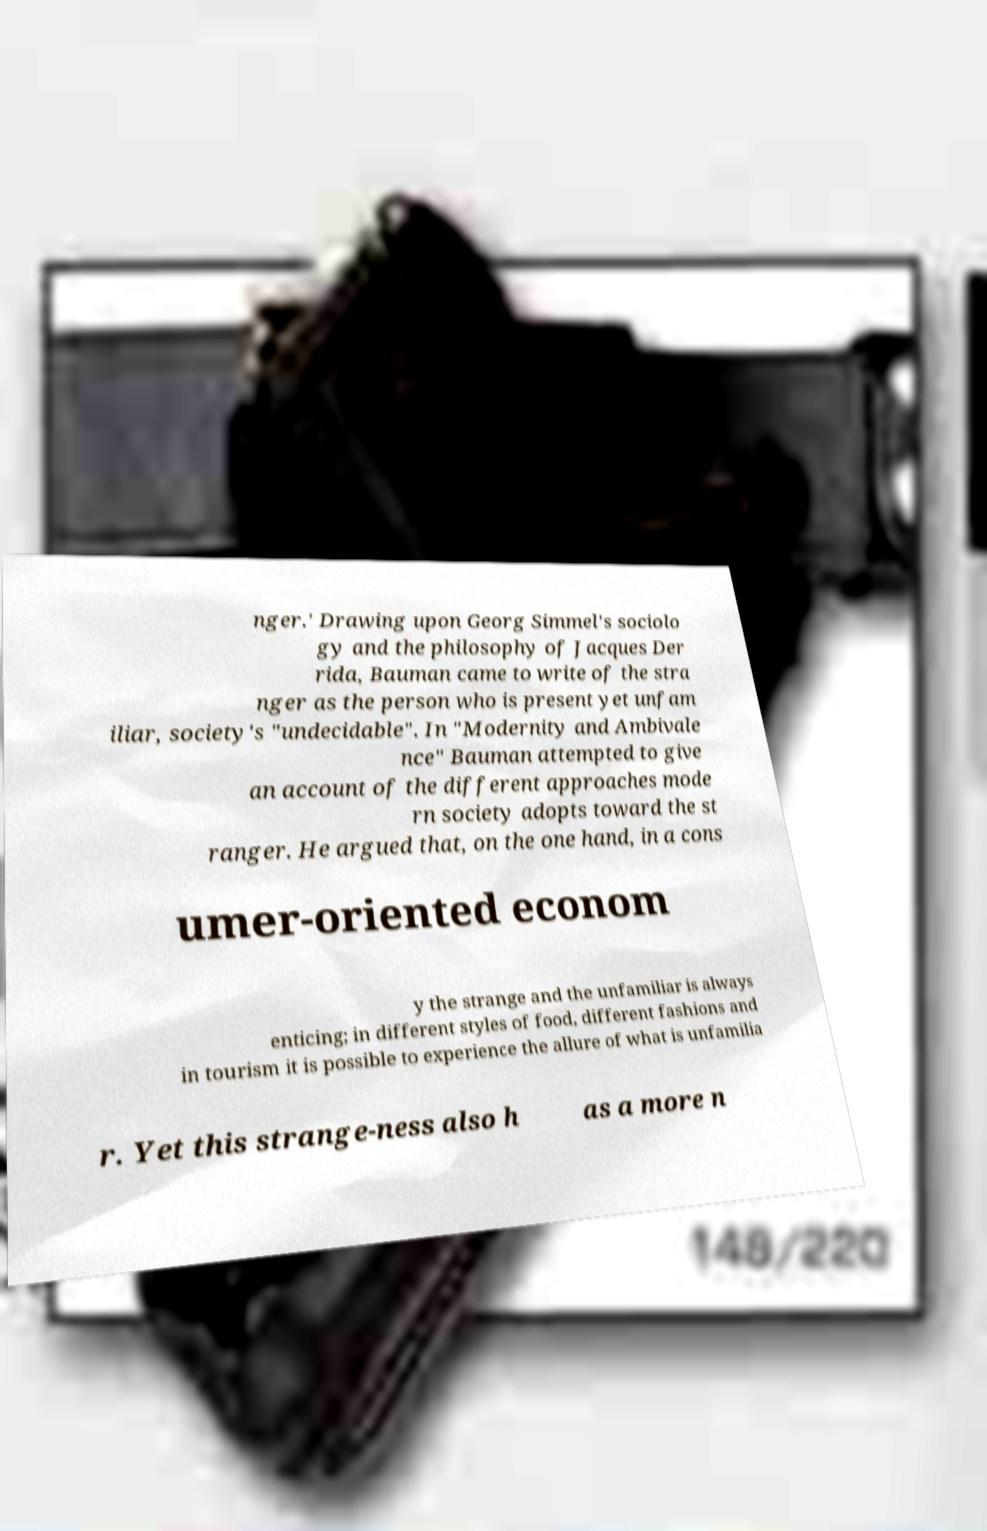Please identify and transcribe the text found in this image. nger.' Drawing upon Georg Simmel's sociolo gy and the philosophy of Jacques Der rida, Bauman came to write of the stra nger as the person who is present yet unfam iliar, society's "undecidable". In "Modernity and Ambivale nce" Bauman attempted to give an account of the different approaches mode rn society adopts toward the st ranger. He argued that, on the one hand, in a cons umer-oriented econom y the strange and the unfamiliar is always enticing; in different styles of food, different fashions and in tourism it is possible to experience the allure of what is unfamilia r. Yet this strange-ness also h as a more n 